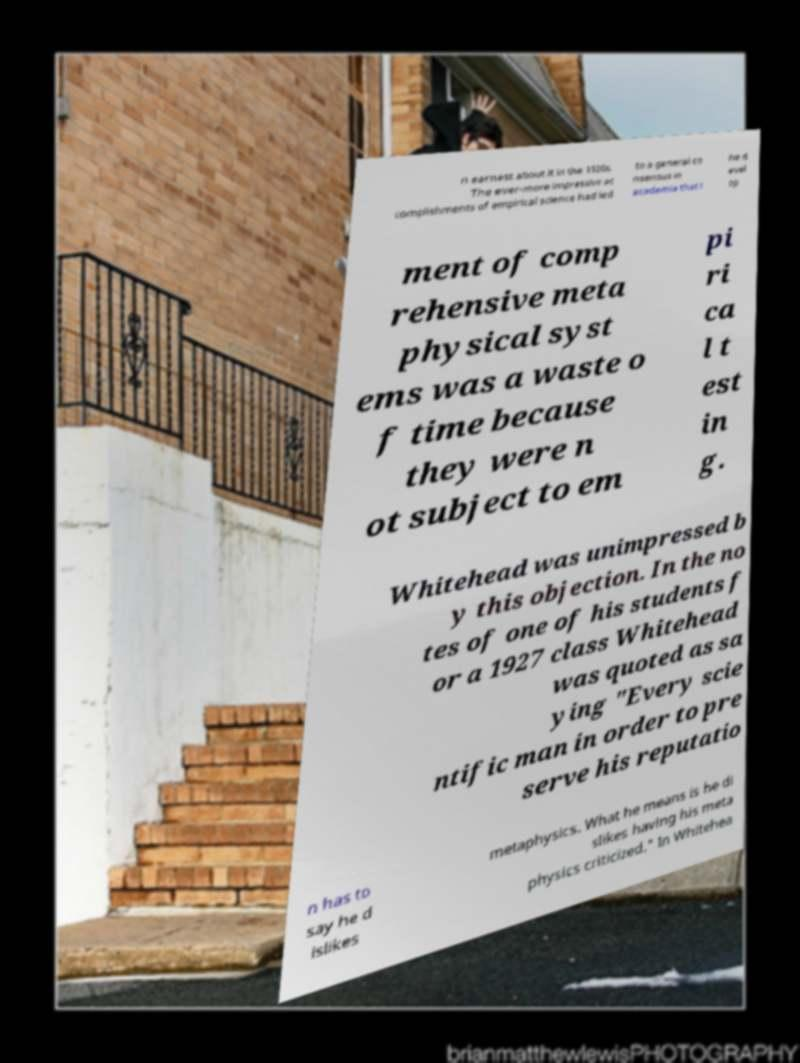What messages or text are displayed in this image? I need them in a readable, typed format. n earnest about it in the 1920s. The ever-more impressive ac complishments of empirical science had led to a general co nsensus in academia that t he d evel op ment of comp rehensive meta physical syst ems was a waste o f time because they were n ot subject to em pi ri ca l t est in g. Whitehead was unimpressed b y this objection. In the no tes of one of his students f or a 1927 class Whitehead was quoted as sa ying "Every scie ntific man in order to pre serve his reputatio n has to say he d islikes metaphysics. What he means is he di slikes having his meta physics criticized." In Whitehea 